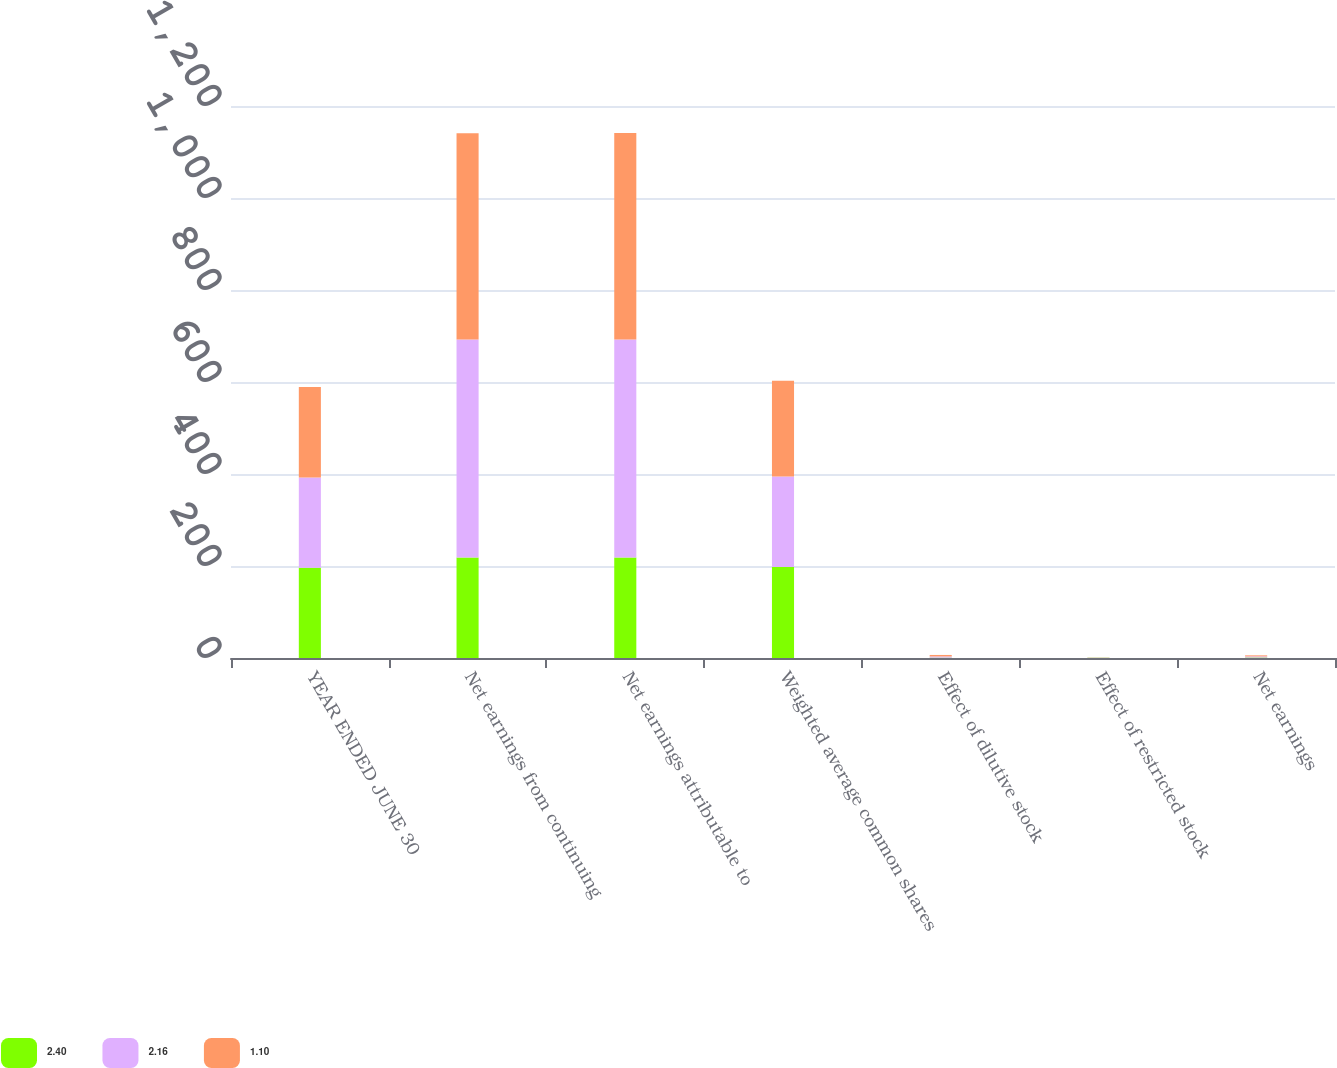Convert chart to OTSL. <chart><loc_0><loc_0><loc_500><loc_500><stacked_bar_chart><ecel><fcel>YEAR ENDED JUNE 30<fcel>Net earnings from continuing<fcel>Net earnings attributable to<fcel>Weighted average common shares<fcel>Effect of dilutive stock<fcel>Effect of restricted stock<fcel>Net earnings<nl><fcel>2.4<fcel>196.3<fcel>218.4<fcel>218.4<fcel>197.7<fcel>0.8<fcel>0.6<fcel>1.11<nl><fcel>2.16<fcel>196.3<fcel>473.8<fcel>473.8<fcel>197.1<fcel>2.6<fcel>0.6<fcel>2.44<nl><fcel>1.1<fcel>196.3<fcel>448.7<fcel>449.2<fcel>207.8<fcel>3.2<fcel>0.2<fcel>2.2<nl></chart> 